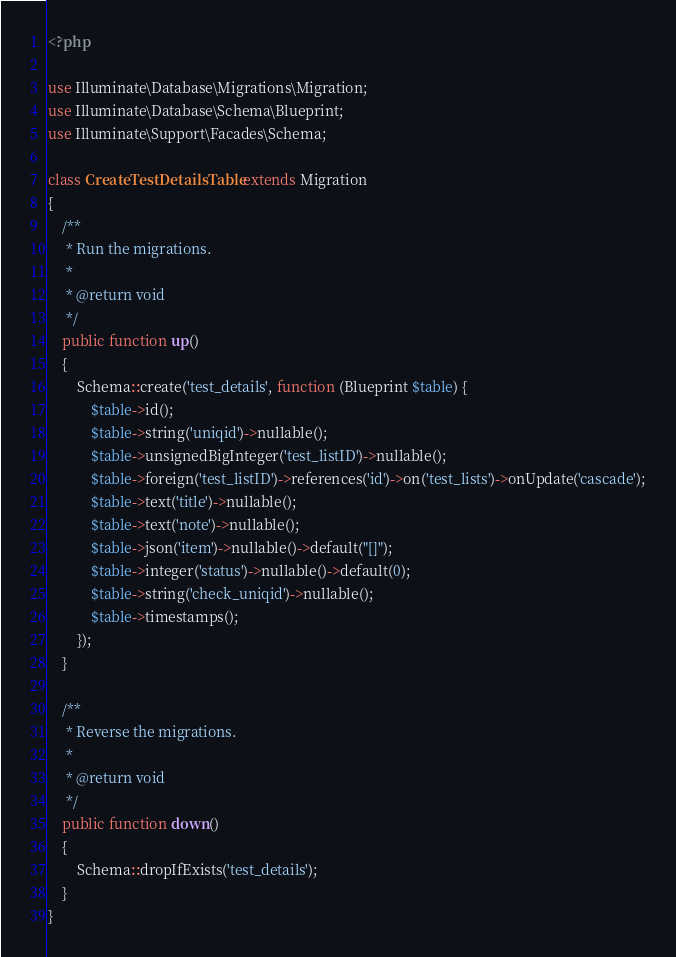<code> <loc_0><loc_0><loc_500><loc_500><_PHP_><?php

use Illuminate\Database\Migrations\Migration;
use Illuminate\Database\Schema\Blueprint;
use Illuminate\Support\Facades\Schema;

class CreateTestDetailsTable extends Migration
{
    /**
     * Run the migrations.
     *
     * @return void
     */
    public function up()
    {
        Schema::create('test_details', function (Blueprint $table) {
            $table->id();
            $table->string('uniqid')->nullable();
            $table->unsignedBigInteger('test_listID')->nullable();
            $table->foreign('test_listID')->references('id')->on('test_lists')->onUpdate('cascade');
            $table->text('title')->nullable();
            $table->text('note')->nullable();
            $table->json('item')->nullable()->default("[]");
            $table->integer('status')->nullable()->default(0);
            $table->string('check_uniqid')->nullable();
            $table->timestamps();
        });
    }

    /**
     * Reverse the migrations.
     *
     * @return void
     */
    public function down()
    {
        Schema::dropIfExists('test_details');
    }
}
</code> 